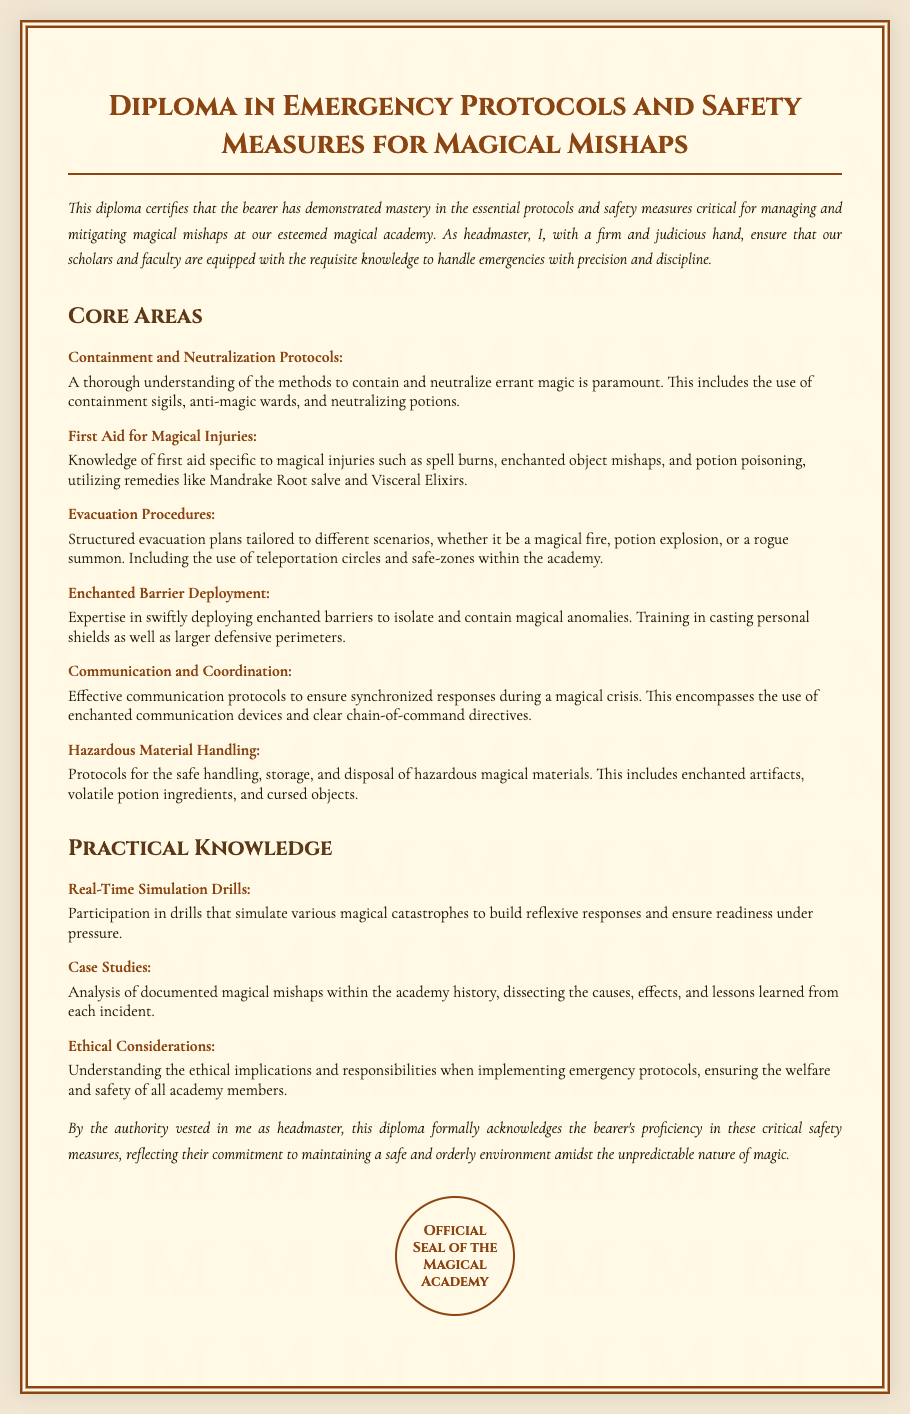What is the title of the diploma? The title is the main heading of the document, which outlines the subject of study.
Answer: Diploma in Emergency Protocols and Safety Measures for Magical Mishaps Who is the headmaster? The headmaster is the authority that certifies the diploma and oversees the academy's safety protocols.
Answer: Headmaster What are containment protocols related to? The area describes the measures designed to handle errant magic effectively.
Answer: Containment and Neutralization Protocols What is a remedy for potion poisoning mentioned? The document lists specific remedies useful for magical injuries.
Answer: Visceral Elixirs What is required for evacuation procedures? The evacuation procedures need to be tailored to specific emergency scenarios described in the document.
Answer: Structured evacuation plans How many core areas are mentioned? The core areas represent critical components of the diploma content.
Answer: Six What is the purpose of real-time simulation drills? The drills are performed to enhance readiness during crises through practice.
Answer: Build reflexive responses What must be considered ethically when implementing protocols? Ethical considerations address the responsibilities towards all academy members during emergencies.
Answer: Welfare and safety What signifies the official acknowledgment of proficiency? The seal represents the formal recognition provided by the headmaster within the diploma.
Answer: Official Seal of the Magical Academy 